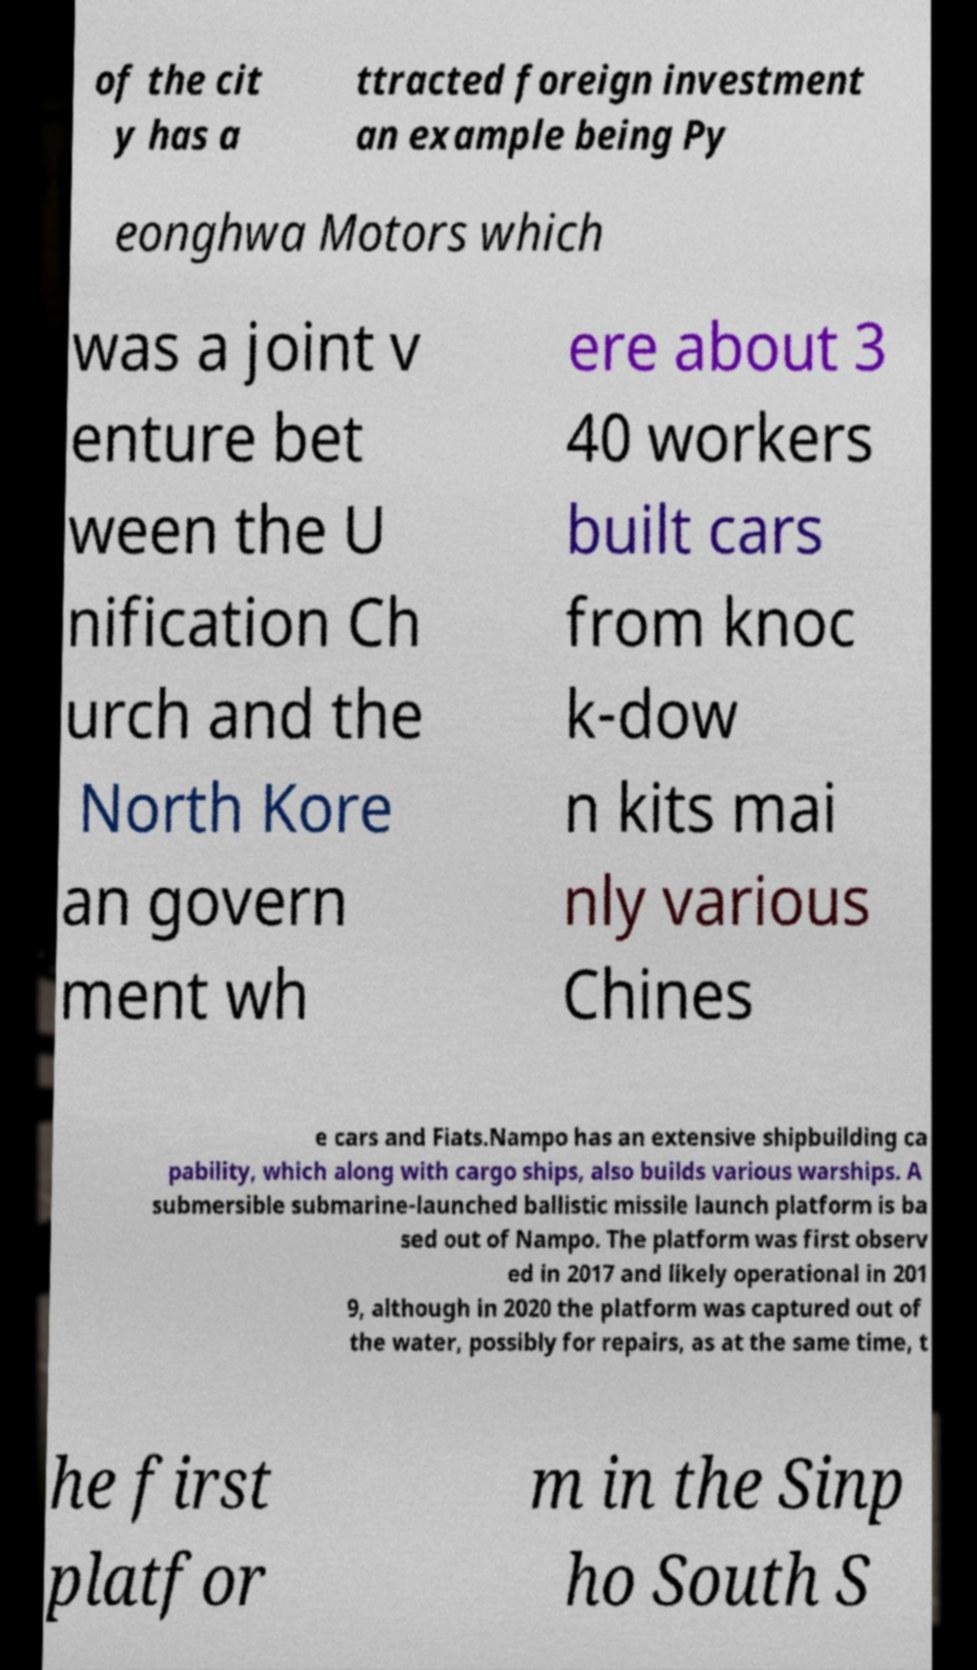Could you assist in decoding the text presented in this image and type it out clearly? of the cit y has a ttracted foreign investment an example being Py eonghwa Motors which was a joint v enture bet ween the U nification Ch urch and the North Kore an govern ment wh ere about 3 40 workers built cars from knoc k-dow n kits mai nly various Chines e cars and Fiats.Nampo has an extensive shipbuilding ca pability, which along with cargo ships, also builds various warships. A submersible submarine-launched ballistic missile launch platform is ba sed out of Nampo. The platform was first observ ed in 2017 and likely operational in 201 9, although in 2020 the platform was captured out of the water, possibly for repairs, as at the same time, t he first platfor m in the Sinp ho South S 